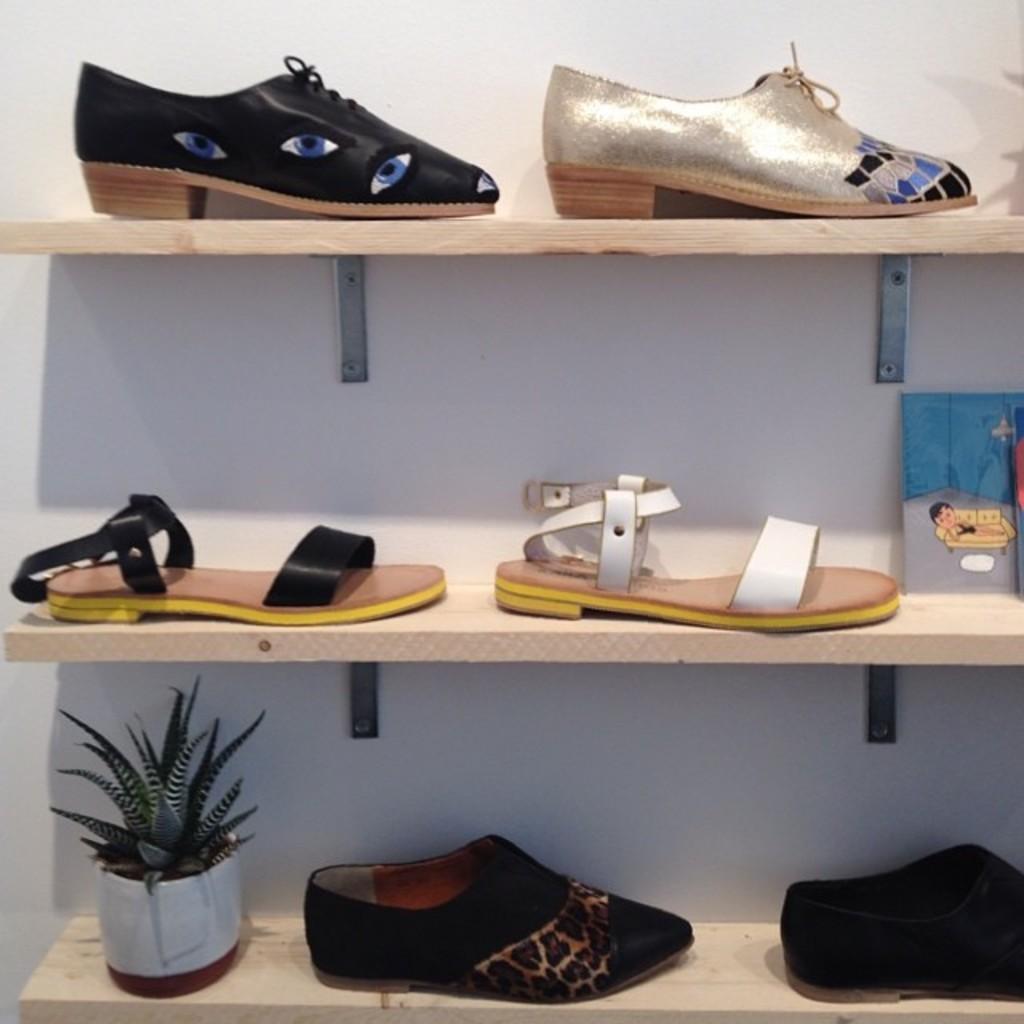How would you summarize this image in a sentence or two? In this picture, we can see the wall with shelves, and some objects in the shelves like foot wear, plant in a pot. 